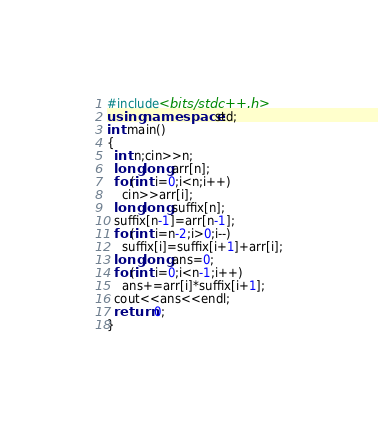<code> <loc_0><loc_0><loc_500><loc_500><_C++_>#include<bits/stdc++.h>
using namespace std;
int main()
{
  int n;cin>>n;
  long long arr[n];
  for(int i=0;i<n;i++)
    cin>>arr[i];
  long long suffix[n];
  suffix[n-1]=arr[n-1];
  for(int i=n-2;i>0;i--)
    suffix[i]=suffix[i+1]+arr[i];
  long long ans=0;
  for(int i=0;i<n-1;i++)
    ans+=arr[i]*suffix[i+1];
  cout<<ans<<endl;
  return 0;
}</code> 